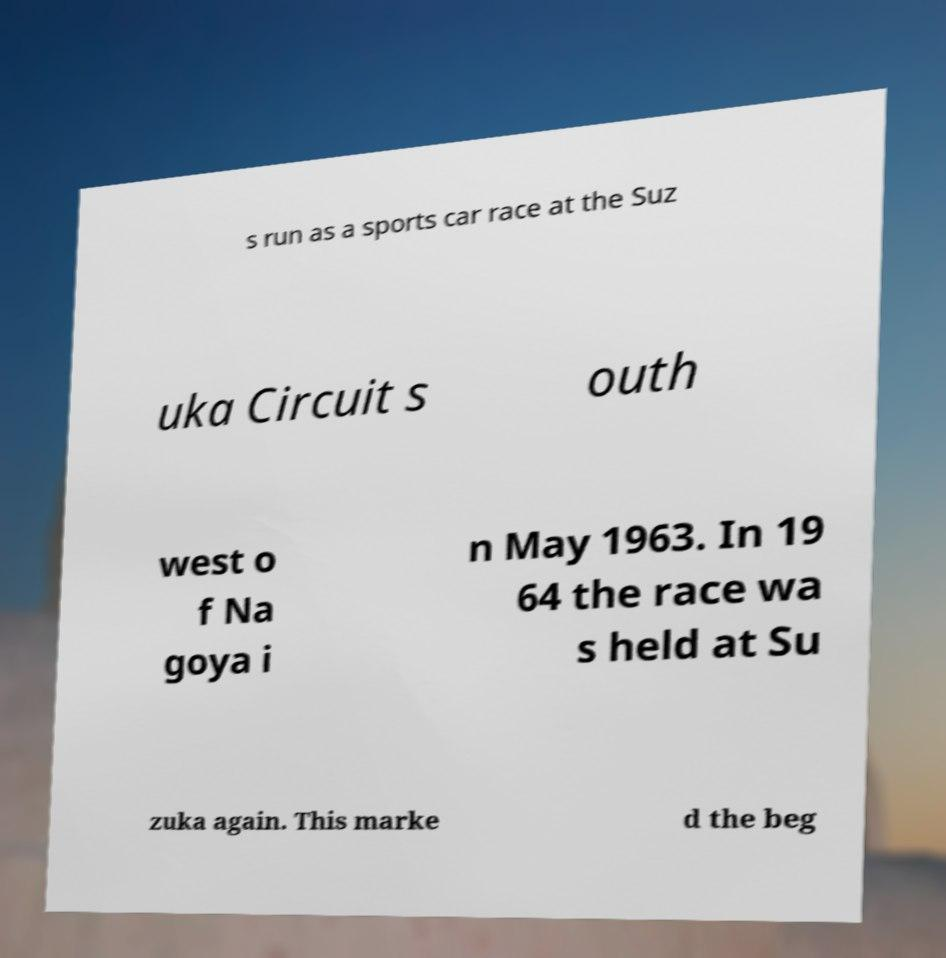Can you accurately transcribe the text from the provided image for me? s run as a sports car race at the Suz uka Circuit s outh west o f Na goya i n May 1963. In 19 64 the race wa s held at Su zuka again. This marke d the beg 